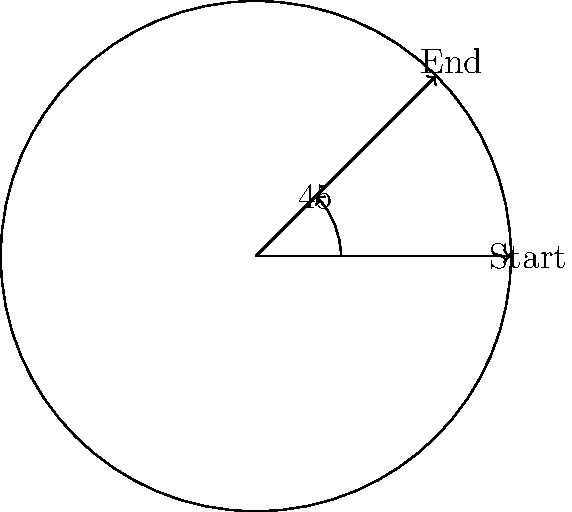During your set at the club where you started your career, you're playing a vinyl record that rotates at 33 1/3 RPM (revolutions per minute). If the needle is at the start position shown in the diagram and plays for 15 seconds, what will be the total rotation angle of the record? Let's approach this step-by-step:

1) First, we need to convert the rotation speed from RPM to degrees per second:
   $33\frac{1}{3}$ RPM = $33\frac{1}{3}$ revolutions per minute
   
2) One revolution is 360°, so:
   $33\frac{1}{3}$ RPM = $33\frac{1}{3} \times 360°$ per minute = 12000° per minute

3) To get degrees per second, we divide by 60:
   $\frac{12000°}{60} = 200°$ per second

4) The record plays for 15 seconds, so we multiply:
   $200° \times 15 = 3000°$

5) However, we need to express this in terms of a single revolution (360°) plus any additional rotation:
   $3000° = 8 \times 360° + 120°$

6) This means the record has made 8 full rotations plus an additional 120°.

7) The total rotation angle is therefore 120°.
Answer: 120° 